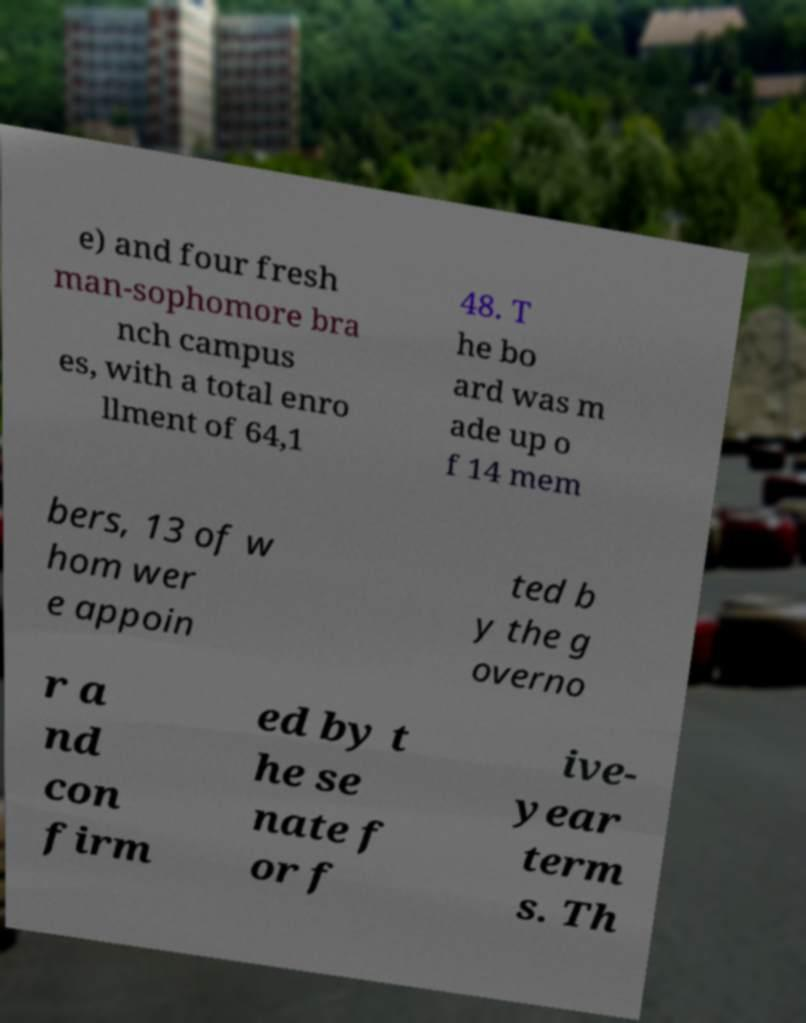For documentation purposes, I need the text within this image transcribed. Could you provide that? e) and four fresh man-sophomore bra nch campus es, with a total enro llment of 64,1 48. T he bo ard was m ade up o f 14 mem bers, 13 of w hom wer e appoin ted b y the g overno r a nd con firm ed by t he se nate f or f ive- year term s. Th 